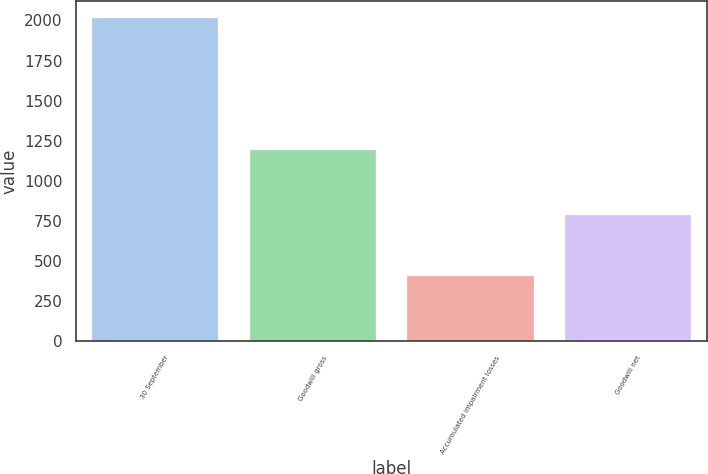<chart> <loc_0><loc_0><loc_500><loc_500><bar_chart><fcel>30 September<fcel>Goodwill gross<fcel>Accumulated impairment losses<fcel>Goodwill net<nl><fcel>2018<fcel>1194.7<fcel>405.8<fcel>788.9<nl></chart> 